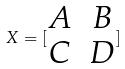<formula> <loc_0><loc_0><loc_500><loc_500>X = [ \begin{matrix} A & B \\ C & D \end{matrix} ]</formula> 